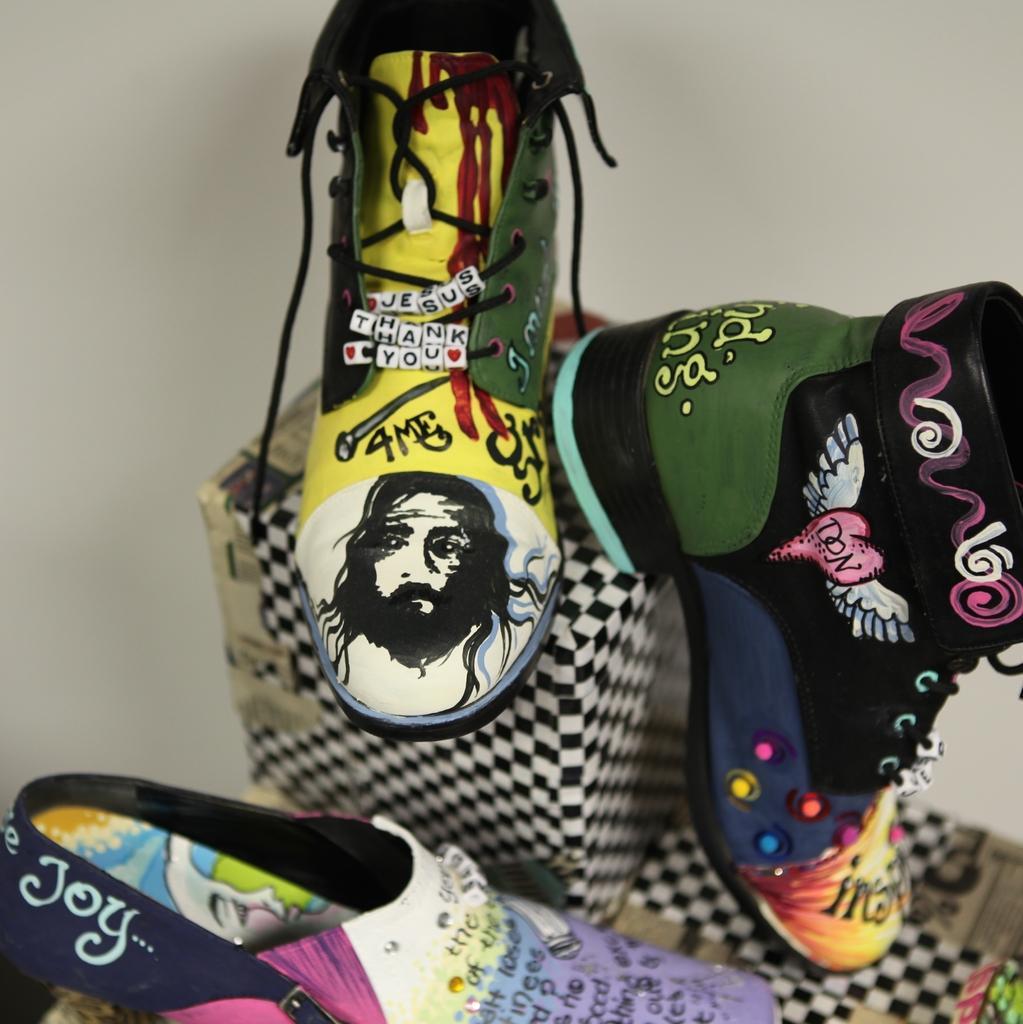Describe this image in one or two sentences. In this picture we can see the different type of shoes which are kept on the cotton boxers. Beside that we can see the wall. 